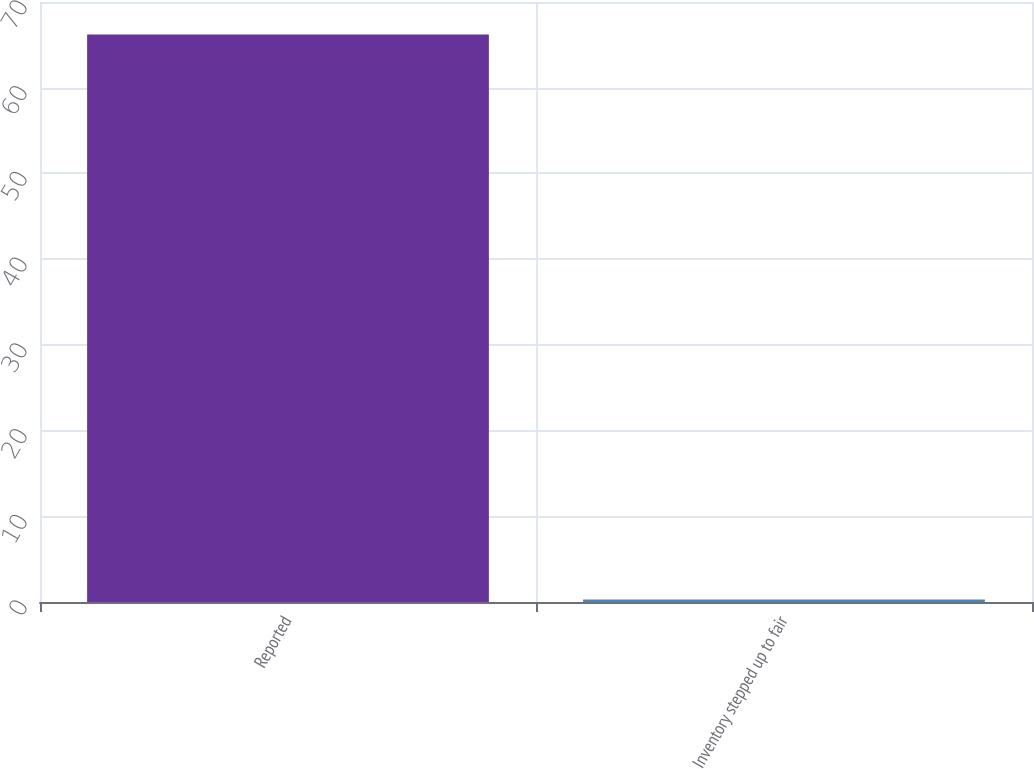Convert chart. <chart><loc_0><loc_0><loc_500><loc_500><bar_chart><fcel>Reported<fcel>Inventory stepped up to fair<nl><fcel>66.2<fcel>0.3<nl></chart> 